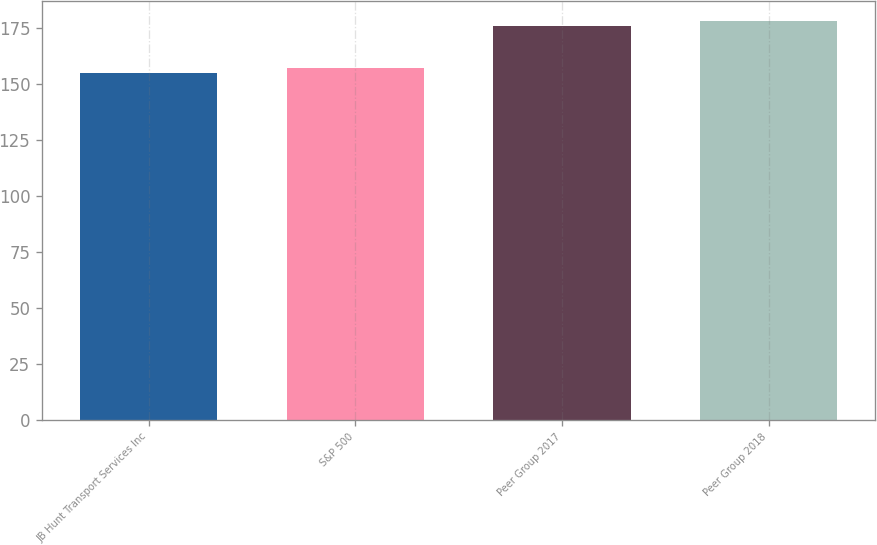Convert chart to OTSL. <chart><loc_0><loc_0><loc_500><loc_500><bar_chart><fcel>JB Hunt Transport Services Inc<fcel>S&P 500<fcel>Peer Group 2017<fcel>Peer Group 2018<nl><fcel>155.01<fcel>157.22<fcel>176.06<fcel>178.24<nl></chart> 